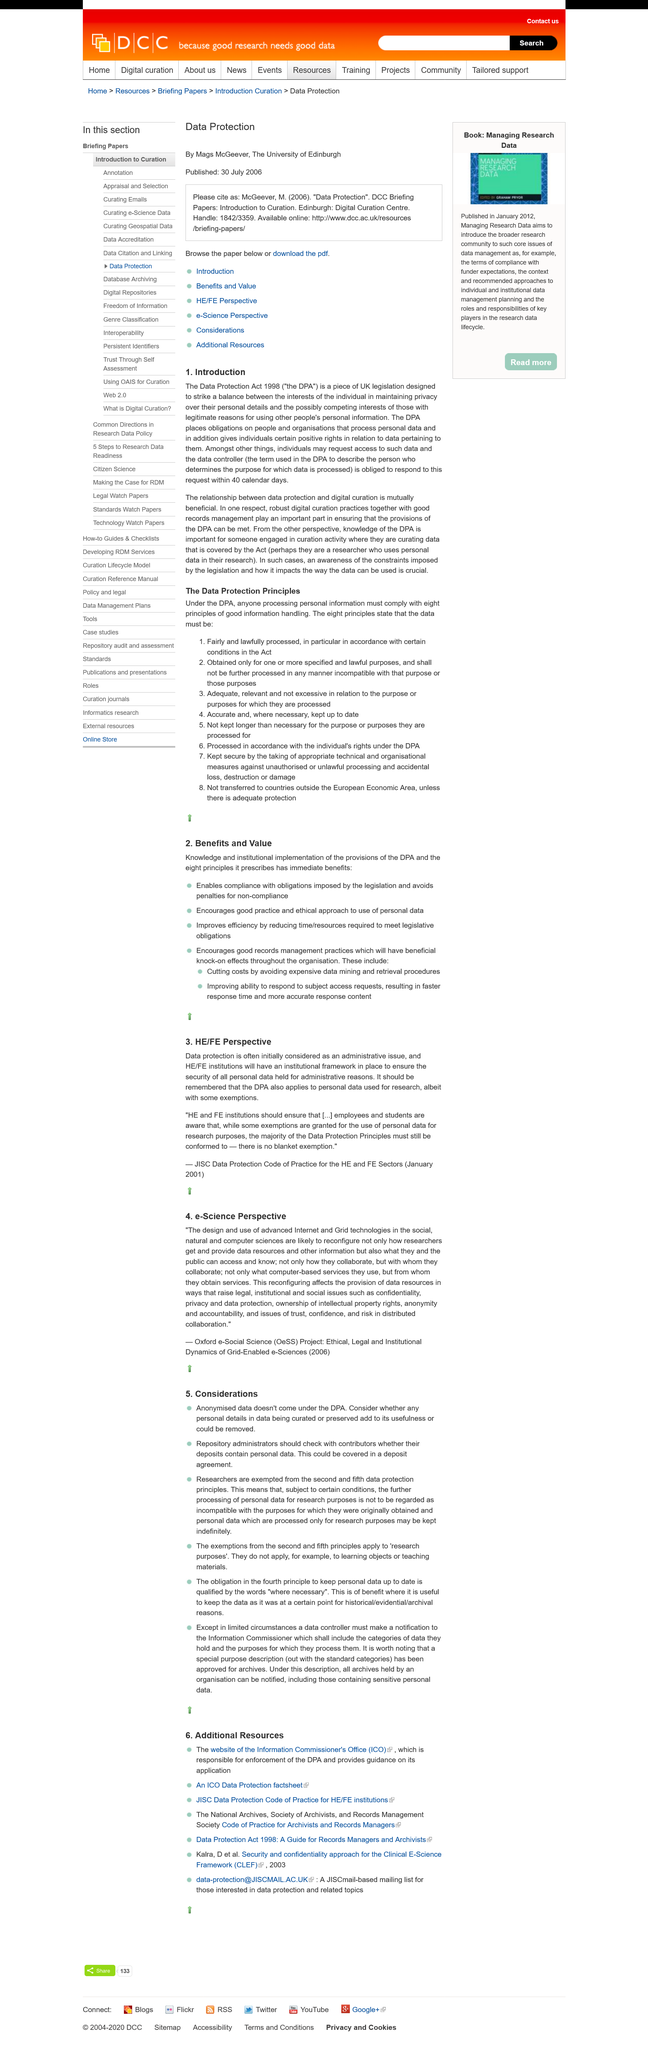List a handful of essential elements in this visual. The Data Protection Act 1998 is commonly referred to as the DPA. The JISC Data Protection Code of Practice was published in 2001. The re-configuration of a system affects the provision of data resources. The acronym OeSS stands for Oxford e-Social Science, which is a collection of digital resources and tools designed for researchers and students in the social sciences. The Data Protection Act (DPA) applies to personal data used for research. 